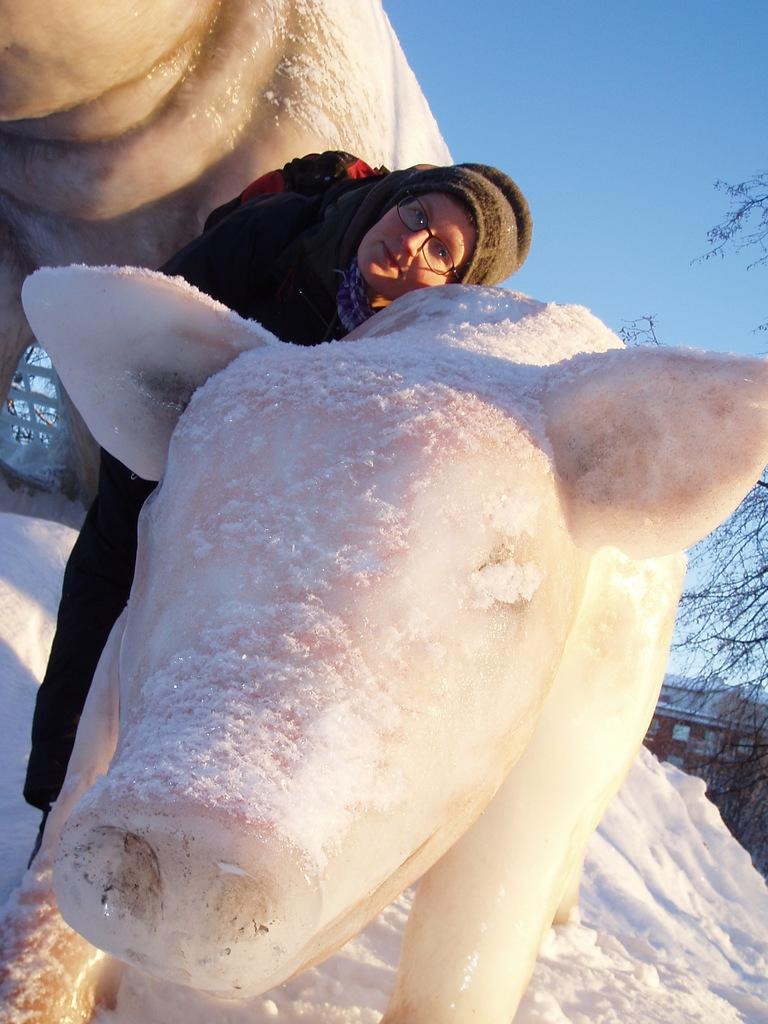Who is present in the image? There is a woman in the image. What is the woman doing in the image? The woman is standing in the image. What is the woman wearing in the image? The woman is wearing a sweater in the image. What can be seen in the background or foreground of the image? There is an ice sculpture in the shape of a pig in the image. What type of letters does the scarecrow hold in the image? There is no scarecrow present in the image, and therefore no letters can be observed. What type of tools does the carpenter use in the image? There is no carpenter present in the image, and therefore no tools can be observed. 